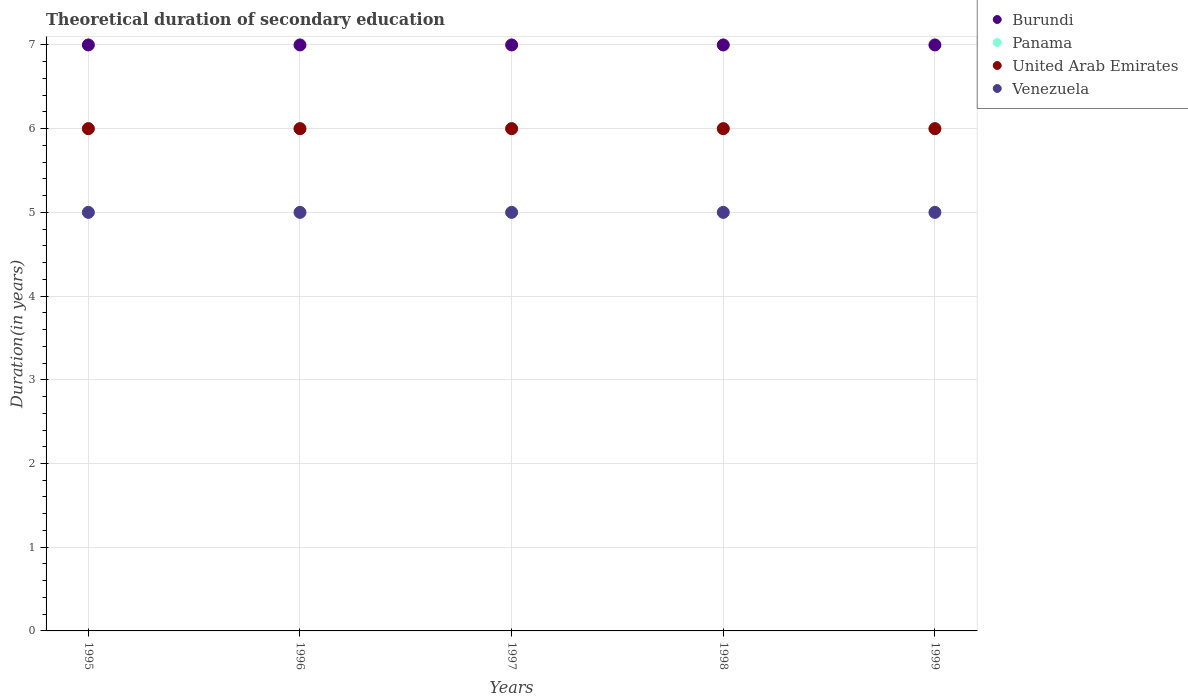Is the number of dotlines equal to the number of legend labels?
Provide a short and direct response. Yes. What is the total theoretical duration of secondary education in Panama in 1995?
Keep it short and to the point. 6. Across all years, what is the maximum total theoretical duration of secondary education in Burundi?
Keep it short and to the point. 7. In which year was the total theoretical duration of secondary education in Venezuela minimum?
Your answer should be very brief. 1995. What is the total total theoretical duration of secondary education in Burundi in the graph?
Provide a short and direct response. 35. What is the difference between the total theoretical duration of secondary education in Burundi in 1997 and the total theoretical duration of secondary education in Panama in 1996?
Your answer should be compact. 1. In the year 1995, what is the difference between the total theoretical duration of secondary education in Burundi and total theoretical duration of secondary education in Panama?
Provide a short and direct response. 1. In how many years, is the total theoretical duration of secondary education in Panama greater than 6.2 years?
Your answer should be compact. 0. What is the difference between the highest and the second highest total theoretical duration of secondary education in Panama?
Your answer should be very brief. 0. In how many years, is the total theoretical duration of secondary education in Venezuela greater than the average total theoretical duration of secondary education in Venezuela taken over all years?
Provide a short and direct response. 0. Is the sum of the total theoretical duration of secondary education in Panama in 1995 and 1996 greater than the maximum total theoretical duration of secondary education in Burundi across all years?
Offer a very short reply. Yes. Is it the case that in every year, the sum of the total theoretical duration of secondary education in Panama and total theoretical duration of secondary education in Burundi  is greater than the sum of total theoretical duration of secondary education in United Arab Emirates and total theoretical duration of secondary education in Venezuela?
Provide a succinct answer. Yes. Is it the case that in every year, the sum of the total theoretical duration of secondary education in Burundi and total theoretical duration of secondary education in United Arab Emirates  is greater than the total theoretical duration of secondary education in Venezuela?
Your answer should be compact. Yes. Is the total theoretical duration of secondary education in Burundi strictly greater than the total theoretical duration of secondary education in United Arab Emirates over the years?
Make the answer very short. Yes. How many dotlines are there?
Offer a very short reply. 4. How many years are there in the graph?
Provide a succinct answer. 5. Are the values on the major ticks of Y-axis written in scientific E-notation?
Your answer should be very brief. No. Does the graph contain any zero values?
Provide a short and direct response. No. Does the graph contain grids?
Keep it short and to the point. Yes. How many legend labels are there?
Make the answer very short. 4. How are the legend labels stacked?
Make the answer very short. Vertical. What is the title of the graph?
Your response must be concise. Theoretical duration of secondary education. What is the label or title of the X-axis?
Offer a very short reply. Years. What is the label or title of the Y-axis?
Offer a terse response. Duration(in years). What is the Duration(in years) of Panama in 1995?
Keep it short and to the point. 6. What is the Duration(in years) in United Arab Emirates in 1995?
Offer a very short reply. 6. What is the Duration(in years) of Venezuela in 1995?
Give a very brief answer. 5. What is the Duration(in years) of Burundi in 1996?
Offer a very short reply. 7. What is the Duration(in years) in Panama in 1996?
Provide a succinct answer. 6. What is the Duration(in years) of Panama in 1997?
Make the answer very short. 6. What is the Duration(in years) in United Arab Emirates in 1997?
Ensure brevity in your answer.  6. What is the Duration(in years) in Burundi in 1998?
Give a very brief answer. 7. What is the Duration(in years) of United Arab Emirates in 1998?
Keep it short and to the point. 6. What is the Duration(in years) in Venezuela in 1998?
Your response must be concise. 5. What is the Duration(in years) of Panama in 1999?
Offer a terse response. 6. What is the Duration(in years) of United Arab Emirates in 1999?
Keep it short and to the point. 6. What is the Duration(in years) of Venezuela in 1999?
Provide a succinct answer. 5. Across all years, what is the maximum Duration(in years) in Panama?
Give a very brief answer. 6. Across all years, what is the maximum Duration(in years) in United Arab Emirates?
Keep it short and to the point. 6. Across all years, what is the minimum Duration(in years) in Burundi?
Your answer should be compact. 7. Across all years, what is the minimum Duration(in years) in Venezuela?
Provide a short and direct response. 5. What is the total Duration(in years) of Burundi in the graph?
Offer a terse response. 35. What is the total Duration(in years) of Panama in the graph?
Give a very brief answer. 30. What is the total Duration(in years) of United Arab Emirates in the graph?
Your answer should be very brief. 30. What is the total Duration(in years) of Venezuela in the graph?
Your response must be concise. 25. What is the difference between the Duration(in years) in Panama in 1995 and that in 1996?
Provide a succinct answer. 0. What is the difference between the Duration(in years) in Venezuela in 1995 and that in 1996?
Keep it short and to the point. 0. What is the difference between the Duration(in years) of Burundi in 1995 and that in 1997?
Provide a succinct answer. 0. What is the difference between the Duration(in years) in Panama in 1995 and that in 1997?
Give a very brief answer. 0. What is the difference between the Duration(in years) of United Arab Emirates in 1995 and that in 1997?
Give a very brief answer. 0. What is the difference between the Duration(in years) in Venezuela in 1995 and that in 1997?
Ensure brevity in your answer.  0. What is the difference between the Duration(in years) of Burundi in 1995 and that in 1998?
Make the answer very short. 0. What is the difference between the Duration(in years) of Panama in 1995 and that in 1998?
Give a very brief answer. 0. What is the difference between the Duration(in years) in Venezuela in 1995 and that in 1998?
Ensure brevity in your answer.  0. What is the difference between the Duration(in years) in Burundi in 1995 and that in 1999?
Offer a terse response. 0. What is the difference between the Duration(in years) in Panama in 1995 and that in 1999?
Make the answer very short. 0. What is the difference between the Duration(in years) in United Arab Emirates in 1995 and that in 1999?
Offer a terse response. 0. What is the difference between the Duration(in years) in Burundi in 1996 and that in 1997?
Make the answer very short. 0. What is the difference between the Duration(in years) in Panama in 1996 and that in 1997?
Your answer should be compact. 0. What is the difference between the Duration(in years) of United Arab Emirates in 1996 and that in 1997?
Offer a very short reply. 0. What is the difference between the Duration(in years) in Venezuela in 1996 and that in 1997?
Ensure brevity in your answer.  0. What is the difference between the Duration(in years) in Burundi in 1996 and that in 1998?
Provide a succinct answer. 0. What is the difference between the Duration(in years) of Burundi in 1997 and that in 1998?
Offer a terse response. 0. What is the difference between the Duration(in years) of Venezuela in 1997 and that in 1998?
Give a very brief answer. 0. What is the difference between the Duration(in years) in Burundi in 1997 and that in 1999?
Your answer should be very brief. 0. What is the difference between the Duration(in years) in Burundi in 1998 and that in 1999?
Give a very brief answer. 0. What is the difference between the Duration(in years) in Venezuela in 1998 and that in 1999?
Ensure brevity in your answer.  0. What is the difference between the Duration(in years) in Burundi in 1995 and the Duration(in years) in Panama in 1996?
Offer a very short reply. 1. What is the difference between the Duration(in years) in Burundi in 1995 and the Duration(in years) in United Arab Emirates in 1996?
Give a very brief answer. 1. What is the difference between the Duration(in years) in Burundi in 1995 and the Duration(in years) in Venezuela in 1996?
Provide a short and direct response. 2. What is the difference between the Duration(in years) in Panama in 1995 and the Duration(in years) in United Arab Emirates in 1996?
Your answer should be very brief. 0. What is the difference between the Duration(in years) in Panama in 1995 and the Duration(in years) in Venezuela in 1996?
Provide a succinct answer. 1. What is the difference between the Duration(in years) in United Arab Emirates in 1995 and the Duration(in years) in Venezuela in 1996?
Ensure brevity in your answer.  1. What is the difference between the Duration(in years) in Burundi in 1995 and the Duration(in years) in Panama in 1997?
Offer a terse response. 1. What is the difference between the Duration(in years) in Panama in 1995 and the Duration(in years) in United Arab Emirates in 1997?
Provide a short and direct response. 0. What is the difference between the Duration(in years) in United Arab Emirates in 1995 and the Duration(in years) in Venezuela in 1997?
Offer a terse response. 1. What is the difference between the Duration(in years) in United Arab Emirates in 1995 and the Duration(in years) in Venezuela in 1998?
Provide a succinct answer. 1. What is the difference between the Duration(in years) of Burundi in 1995 and the Duration(in years) of Venezuela in 1999?
Provide a succinct answer. 2. What is the difference between the Duration(in years) of Panama in 1995 and the Duration(in years) of United Arab Emirates in 1999?
Offer a terse response. 0. What is the difference between the Duration(in years) in United Arab Emirates in 1995 and the Duration(in years) in Venezuela in 1999?
Offer a terse response. 1. What is the difference between the Duration(in years) in Burundi in 1996 and the Duration(in years) in United Arab Emirates in 1997?
Provide a succinct answer. 1. What is the difference between the Duration(in years) of Burundi in 1996 and the Duration(in years) of Venezuela in 1997?
Offer a terse response. 2. What is the difference between the Duration(in years) in Panama in 1996 and the Duration(in years) in Venezuela in 1997?
Keep it short and to the point. 1. What is the difference between the Duration(in years) in United Arab Emirates in 1996 and the Duration(in years) in Venezuela in 1997?
Provide a short and direct response. 1. What is the difference between the Duration(in years) in Burundi in 1996 and the Duration(in years) in United Arab Emirates in 1998?
Your answer should be very brief. 1. What is the difference between the Duration(in years) in Burundi in 1996 and the Duration(in years) in Venezuela in 1998?
Make the answer very short. 2. What is the difference between the Duration(in years) of Panama in 1996 and the Duration(in years) of United Arab Emirates in 1998?
Your response must be concise. 0. What is the difference between the Duration(in years) of Panama in 1996 and the Duration(in years) of Venezuela in 1998?
Give a very brief answer. 1. What is the difference between the Duration(in years) of Burundi in 1996 and the Duration(in years) of United Arab Emirates in 1999?
Your answer should be very brief. 1. What is the difference between the Duration(in years) of Panama in 1996 and the Duration(in years) of Venezuela in 1999?
Your answer should be compact. 1. What is the difference between the Duration(in years) of Burundi in 1997 and the Duration(in years) of Panama in 1998?
Offer a terse response. 1. What is the difference between the Duration(in years) in Burundi in 1997 and the Duration(in years) in Venezuela in 1998?
Ensure brevity in your answer.  2. What is the difference between the Duration(in years) in Panama in 1997 and the Duration(in years) in Venezuela in 1998?
Give a very brief answer. 1. What is the difference between the Duration(in years) of United Arab Emirates in 1997 and the Duration(in years) of Venezuela in 1998?
Your answer should be compact. 1. What is the difference between the Duration(in years) of Burundi in 1997 and the Duration(in years) of Panama in 1999?
Keep it short and to the point. 1. What is the difference between the Duration(in years) in Burundi in 1997 and the Duration(in years) in United Arab Emirates in 1999?
Offer a terse response. 1. What is the difference between the Duration(in years) of Panama in 1997 and the Duration(in years) of United Arab Emirates in 1999?
Offer a very short reply. 0. What is the difference between the Duration(in years) in United Arab Emirates in 1997 and the Duration(in years) in Venezuela in 1999?
Offer a terse response. 1. What is the difference between the Duration(in years) of Burundi in 1998 and the Duration(in years) of United Arab Emirates in 1999?
Your response must be concise. 1. What is the difference between the Duration(in years) of Panama in 1998 and the Duration(in years) of Venezuela in 1999?
Your answer should be very brief. 1. What is the average Duration(in years) of Burundi per year?
Your answer should be compact. 7. What is the average Duration(in years) in Panama per year?
Your answer should be very brief. 6. What is the average Duration(in years) of United Arab Emirates per year?
Keep it short and to the point. 6. In the year 1995, what is the difference between the Duration(in years) of Burundi and Duration(in years) of Panama?
Offer a terse response. 1. In the year 1995, what is the difference between the Duration(in years) in Burundi and Duration(in years) in United Arab Emirates?
Your answer should be compact. 1. In the year 1995, what is the difference between the Duration(in years) of Panama and Duration(in years) of United Arab Emirates?
Your response must be concise. 0. In the year 1995, what is the difference between the Duration(in years) in United Arab Emirates and Duration(in years) in Venezuela?
Offer a very short reply. 1. In the year 1996, what is the difference between the Duration(in years) in Burundi and Duration(in years) in United Arab Emirates?
Give a very brief answer. 1. In the year 1996, what is the difference between the Duration(in years) in Burundi and Duration(in years) in Venezuela?
Your answer should be very brief. 2. In the year 1996, what is the difference between the Duration(in years) of Panama and Duration(in years) of Venezuela?
Your answer should be compact. 1. In the year 1996, what is the difference between the Duration(in years) in United Arab Emirates and Duration(in years) in Venezuela?
Your answer should be very brief. 1. In the year 1997, what is the difference between the Duration(in years) of Burundi and Duration(in years) of Panama?
Your response must be concise. 1. In the year 1997, what is the difference between the Duration(in years) of Panama and Duration(in years) of United Arab Emirates?
Your answer should be compact. 0. In the year 1997, what is the difference between the Duration(in years) in United Arab Emirates and Duration(in years) in Venezuela?
Provide a short and direct response. 1. In the year 1998, what is the difference between the Duration(in years) in Burundi and Duration(in years) in United Arab Emirates?
Make the answer very short. 1. In the year 1998, what is the difference between the Duration(in years) in Burundi and Duration(in years) in Venezuela?
Your response must be concise. 2. In the year 1998, what is the difference between the Duration(in years) in Panama and Duration(in years) in Venezuela?
Ensure brevity in your answer.  1. In the year 1998, what is the difference between the Duration(in years) of United Arab Emirates and Duration(in years) of Venezuela?
Provide a succinct answer. 1. In the year 1999, what is the difference between the Duration(in years) in Burundi and Duration(in years) in United Arab Emirates?
Offer a terse response. 1. In the year 1999, what is the difference between the Duration(in years) in United Arab Emirates and Duration(in years) in Venezuela?
Give a very brief answer. 1. What is the ratio of the Duration(in years) in Burundi in 1995 to that in 1996?
Offer a very short reply. 1. What is the ratio of the Duration(in years) of United Arab Emirates in 1995 to that in 1996?
Ensure brevity in your answer.  1. What is the ratio of the Duration(in years) of Burundi in 1995 to that in 1997?
Your answer should be very brief. 1. What is the ratio of the Duration(in years) of United Arab Emirates in 1995 to that in 1997?
Your answer should be very brief. 1. What is the ratio of the Duration(in years) in Venezuela in 1995 to that in 1997?
Your answer should be compact. 1. What is the ratio of the Duration(in years) in Burundi in 1995 to that in 1998?
Offer a terse response. 1. What is the ratio of the Duration(in years) of Panama in 1995 to that in 1999?
Offer a terse response. 1. What is the ratio of the Duration(in years) in United Arab Emirates in 1995 to that in 1999?
Provide a short and direct response. 1. What is the ratio of the Duration(in years) of Venezuela in 1995 to that in 1999?
Keep it short and to the point. 1. What is the ratio of the Duration(in years) of Panama in 1996 to that in 1997?
Make the answer very short. 1. What is the ratio of the Duration(in years) in United Arab Emirates in 1996 to that in 1998?
Your answer should be compact. 1. What is the ratio of the Duration(in years) of Burundi in 1996 to that in 1999?
Ensure brevity in your answer.  1. What is the ratio of the Duration(in years) of United Arab Emirates in 1996 to that in 1999?
Your answer should be very brief. 1. What is the ratio of the Duration(in years) of Venezuela in 1996 to that in 1999?
Your answer should be very brief. 1. What is the ratio of the Duration(in years) of Burundi in 1997 to that in 1998?
Provide a succinct answer. 1. What is the ratio of the Duration(in years) of Burundi in 1997 to that in 1999?
Provide a succinct answer. 1. What is the ratio of the Duration(in years) of Panama in 1997 to that in 1999?
Your response must be concise. 1. What is the ratio of the Duration(in years) of United Arab Emirates in 1997 to that in 1999?
Ensure brevity in your answer.  1. What is the ratio of the Duration(in years) in Panama in 1998 to that in 1999?
Make the answer very short. 1. What is the ratio of the Duration(in years) in United Arab Emirates in 1998 to that in 1999?
Provide a short and direct response. 1. What is the ratio of the Duration(in years) in Venezuela in 1998 to that in 1999?
Your answer should be very brief. 1. What is the difference between the highest and the second highest Duration(in years) in Burundi?
Make the answer very short. 0. What is the difference between the highest and the second highest Duration(in years) in Panama?
Ensure brevity in your answer.  0. What is the difference between the highest and the lowest Duration(in years) in Panama?
Provide a succinct answer. 0. 